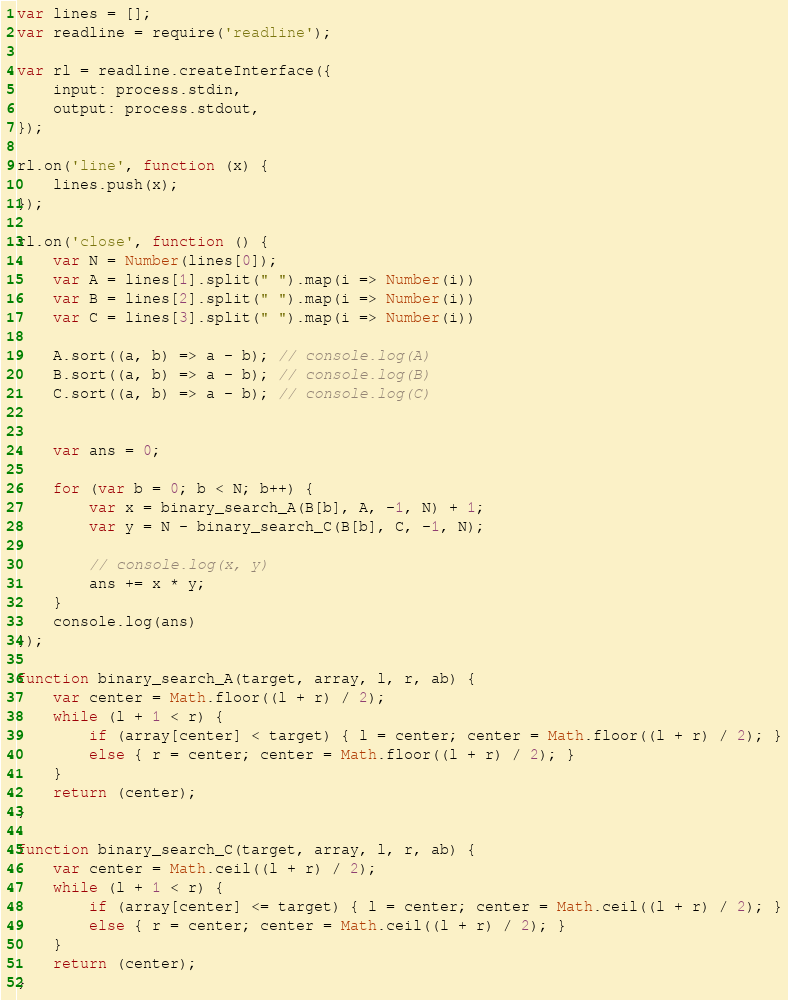<code> <loc_0><loc_0><loc_500><loc_500><_JavaScript_>var lines = [];
var readline = require('readline');

var rl = readline.createInterface({
    input: process.stdin,
    output: process.stdout,
});

rl.on('line', function (x) {
    lines.push(x);
});

rl.on('close', function () {
    var N = Number(lines[0]);
    var A = lines[1].split(" ").map(i => Number(i))
    var B = lines[2].split(" ").map(i => Number(i))
    var C = lines[3].split(" ").map(i => Number(i))

    A.sort((a, b) => a - b); // console.log(A)
    B.sort((a, b) => a - b); // console.log(B)
    C.sort((a, b) => a - b); // console.log(C)


    var ans = 0;

    for (var b = 0; b < N; b++) {
        var x = binary_search_A(B[b], A, -1, N) + 1;
        var y = N - binary_search_C(B[b], C, -1, N);

        // console.log(x, y)
        ans += x * y;
    }
    console.log(ans)
});

function binary_search_A(target, array, l, r, ab) {
    var center = Math.floor((l + r) / 2);
    while (l + 1 < r) {
        if (array[center] < target) { l = center; center = Math.floor((l + r) / 2); }
        else { r = center; center = Math.floor((l + r) / 2); }
    }
    return (center);
}

function binary_search_C(target, array, l, r, ab) {
    var center = Math.ceil((l + r) / 2);
    while (l + 1 < r) {
        if (array[center] <= target) { l = center; center = Math.ceil((l + r) / 2); }
        else { r = center; center = Math.ceil((l + r) / 2); }
    }
    return (center);
}
</code> 